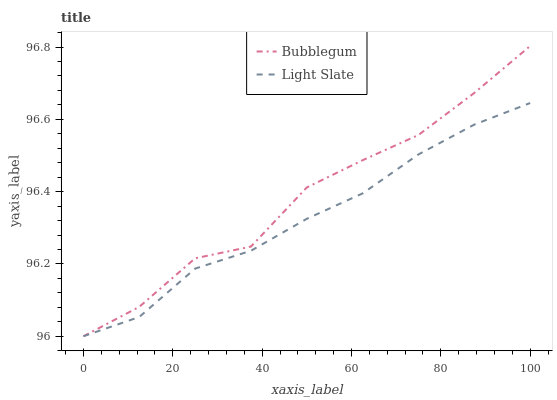Does Light Slate have the minimum area under the curve?
Answer yes or no. Yes. Does Bubblegum have the maximum area under the curve?
Answer yes or no. Yes. Does Bubblegum have the minimum area under the curve?
Answer yes or no. No. Is Light Slate the smoothest?
Answer yes or no. Yes. Is Bubblegum the roughest?
Answer yes or no. Yes. Is Bubblegum the smoothest?
Answer yes or no. No. Does Light Slate have the lowest value?
Answer yes or no. Yes. Does Bubblegum have the highest value?
Answer yes or no. Yes. Does Light Slate intersect Bubblegum?
Answer yes or no. Yes. Is Light Slate less than Bubblegum?
Answer yes or no. No. Is Light Slate greater than Bubblegum?
Answer yes or no. No. 